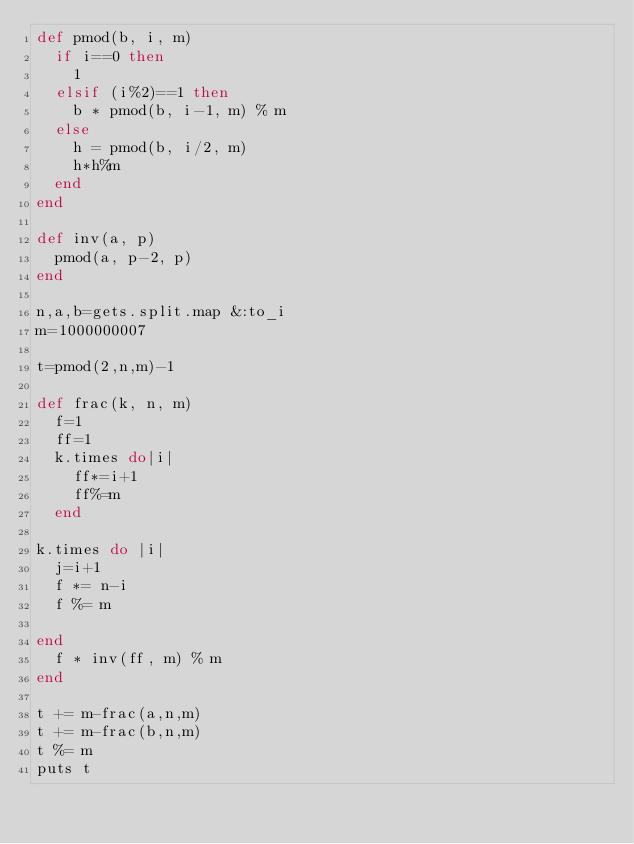<code> <loc_0><loc_0><loc_500><loc_500><_Ruby_>def pmod(b, i, m)
  if i==0 then
    1
  elsif (i%2)==1 then
    b * pmod(b, i-1, m) % m
  else
    h = pmod(b, i/2, m)
    h*h%m
  end
end
    
def inv(a, p)
  pmod(a, p-2, p)
end
    
n,a,b=gets.split.map &:to_i
m=1000000007

t=pmod(2,n,m)-1

def frac(k, n, m)
  f=1
  ff=1
  k.times do|i|
    ff*=i+1
    ff%=m
  end
  
k.times do |i|
  j=i+1
  f *= n-i
  f %= m
  
end
  f * inv(ff, m) % m
end

t += m-frac(a,n,m)
t += m-frac(b,n,m)
t %= m
puts t
  </code> 